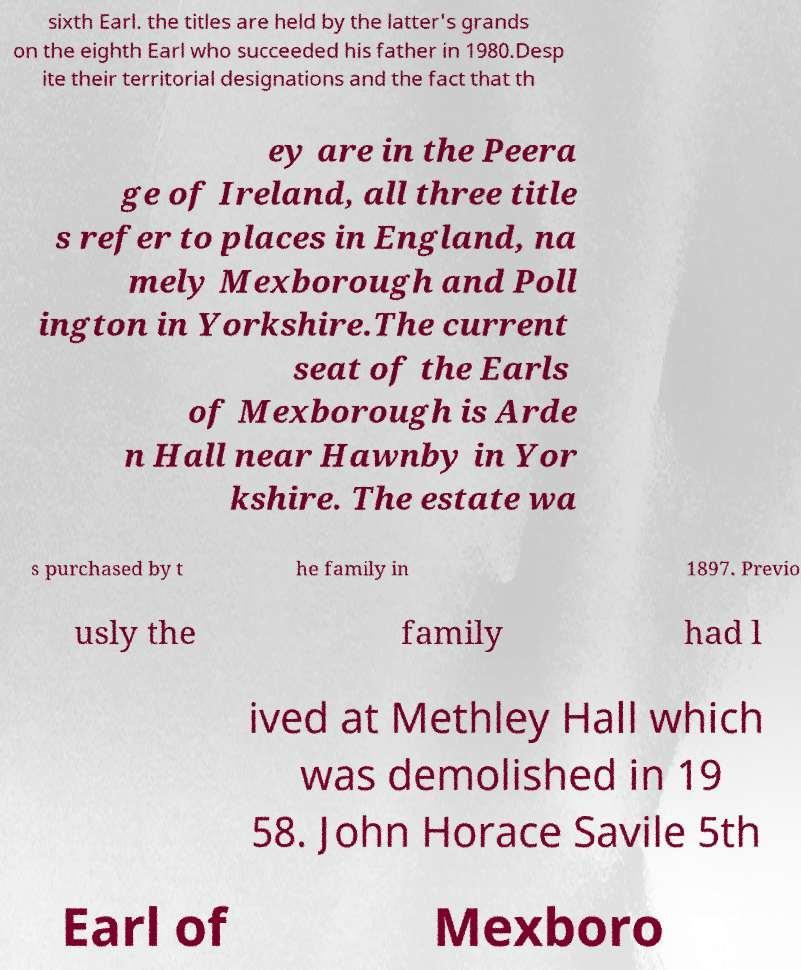What messages or text are displayed in this image? I need them in a readable, typed format. sixth Earl. the titles are held by the latter's grands on the eighth Earl who succeeded his father in 1980.Desp ite their territorial designations and the fact that th ey are in the Peera ge of Ireland, all three title s refer to places in England, na mely Mexborough and Poll ington in Yorkshire.The current seat of the Earls of Mexborough is Arde n Hall near Hawnby in Yor kshire. The estate wa s purchased by t he family in 1897. Previo usly the family had l ived at Methley Hall which was demolished in 19 58. John Horace Savile 5th Earl of Mexboro 